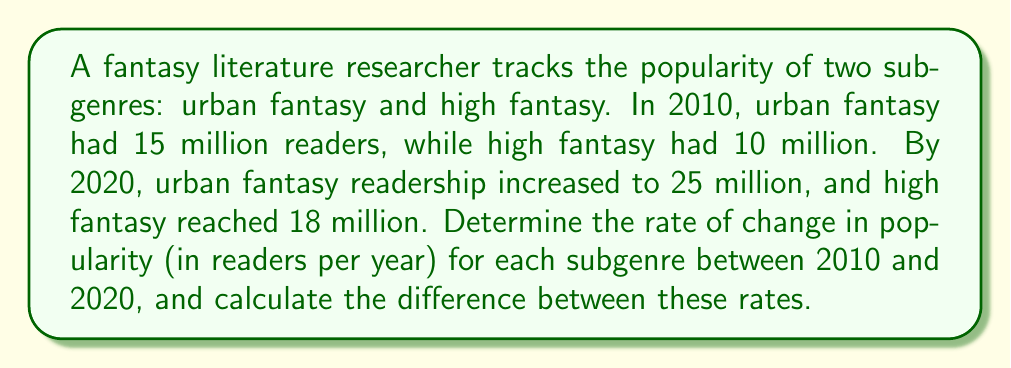Teach me how to tackle this problem. Let's approach this step-by-step:

1. For urban fantasy:
   - Initial readers (2010): 15 million
   - Final readers (2020): 25 million
   - Time period: 10 years
   
   Rate of change = $\frac{\text{Change in readers}}{\text{Time period}}$
   
   $$\text{Rate}_{\text{urban}} = \frac{25,000,000 - 15,000,000}{10} = \frac{10,000,000}{10} = 1,000,000 \text{ readers/year}$$

2. For high fantasy:
   - Initial readers (2010): 10 million
   - Final readers (2020): 18 million
   - Time period: 10 years
   
   $$\text{Rate}_{\text{high}} = \frac{18,000,000 - 10,000,000}{10} = \frac{8,000,000}{10} = 800,000 \text{ readers/year}$$

3. To find the difference between these rates:
   
   $$\text{Difference} = \text{Rate}_{\text{urban}} - \text{Rate}_{\text{high}} = 1,000,000 - 800,000 = 200,000 \text{ readers/year}$$

Thus, urban fantasy's popularity grew at a rate 200,000 readers per year faster than high fantasy's.
Answer: 200,000 readers/year 